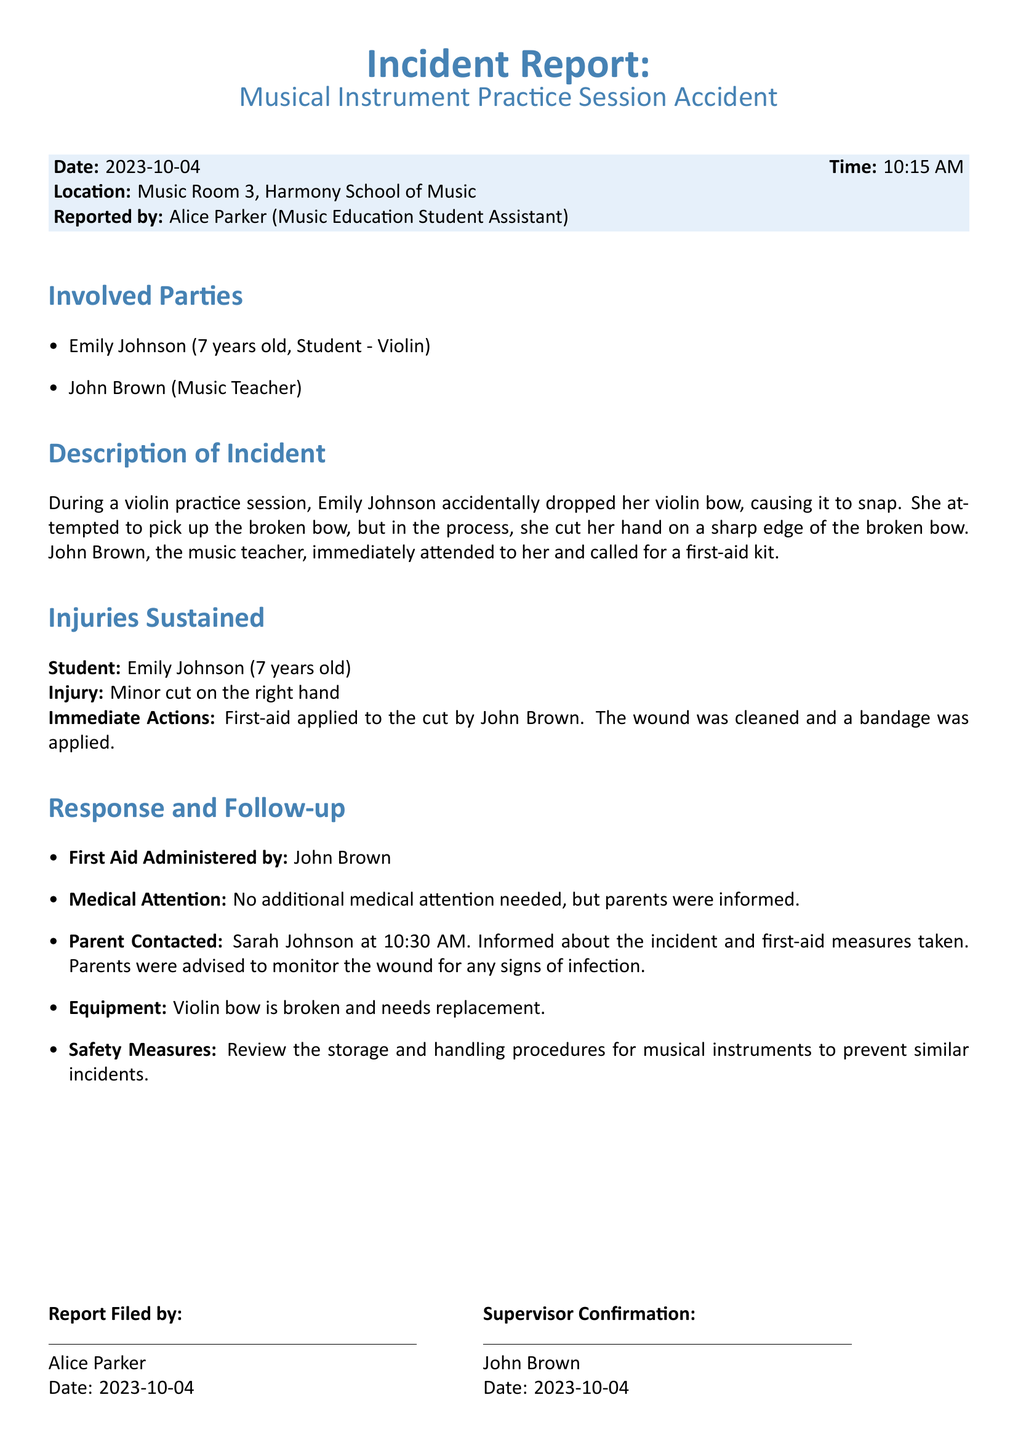What is the date of the incident? The date of the incident is explicitly mentioned in the report.
Answer: 2023-10-04 Who reported the incident? The report states the name of the person who reported the incident.
Answer: Alice Parker What instrument was involved in the accident? The report specifies the instrument that was being used during the accident.
Answer: Violin What type of injury did Emily Johnson sustain? The report details the nature of the injury sustained by the student.
Answer: Minor cut on the right hand What actions were taken immediately after the injury? The report outlines the immediate actions that were taken following the injury.
Answer: First-aid applied to the cut by John Brown Who was contacted about the incident? The report mentions who was informed regarding the incident.
Answer: Sarah Johnson How was the violin bow damaged? The explanation in the report provides information on how the bow got damaged.
Answer: It snapped What time was the parent contacted? The report indicates the specific time the parent was contacted.
Answer: 10:30 AM What measures are suggested to prevent future incidents? The report lists recommendations for safety measures to avoid similar incidents.
Answer: Review the storage and handling procedures for musical instruments 